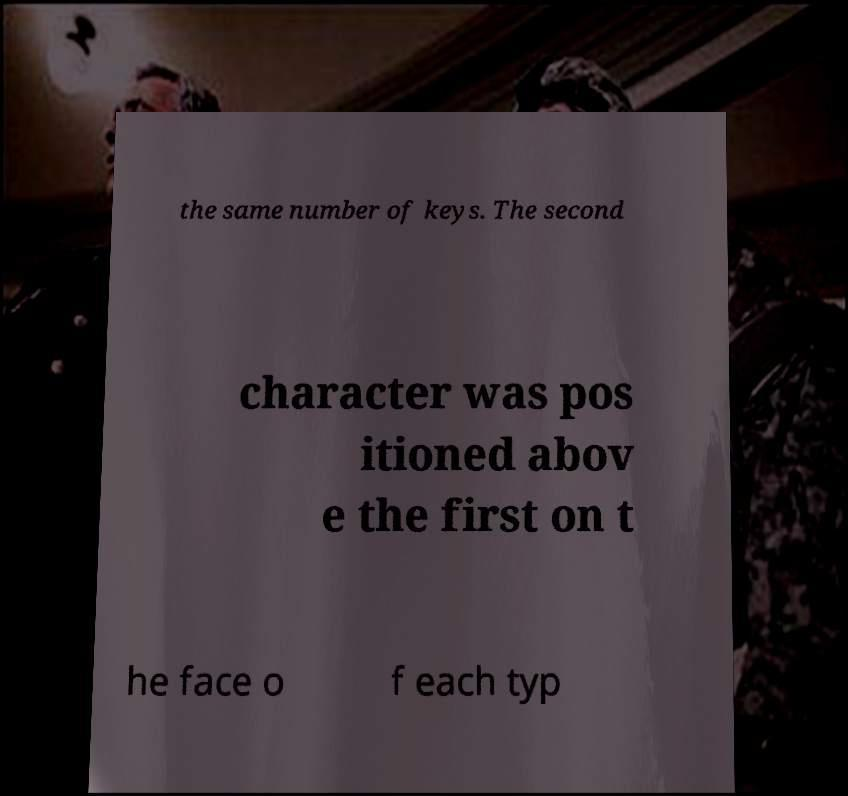For documentation purposes, I need the text within this image transcribed. Could you provide that? the same number of keys. The second character was pos itioned abov e the first on t he face o f each typ 